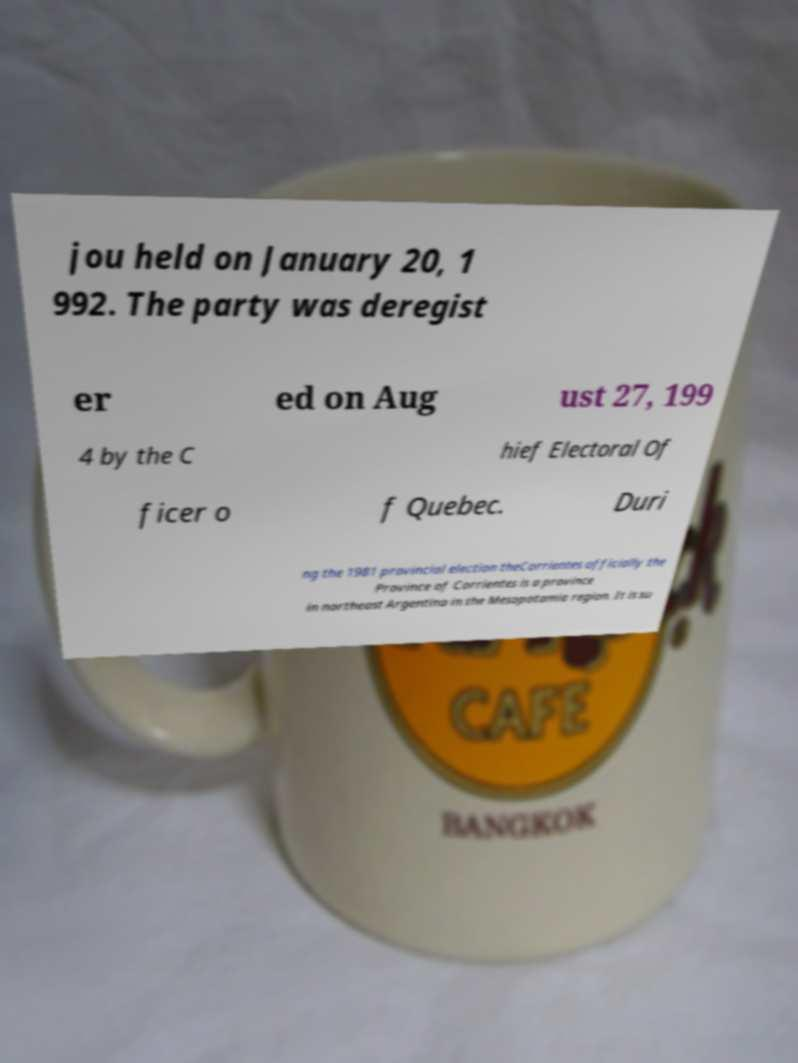Please read and relay the text visible in this image. What does it say? jou held on January 20, 1 992. The party was deregist er ed on Aug ust 27, 199 4 by the C hief Electoral Of ficer o f Quebec. Duri ng the 1981 provincial election theCorrientes officially the Province of Corrientes is a province in northeast Argentina in the Mesopotamia region. It is su 